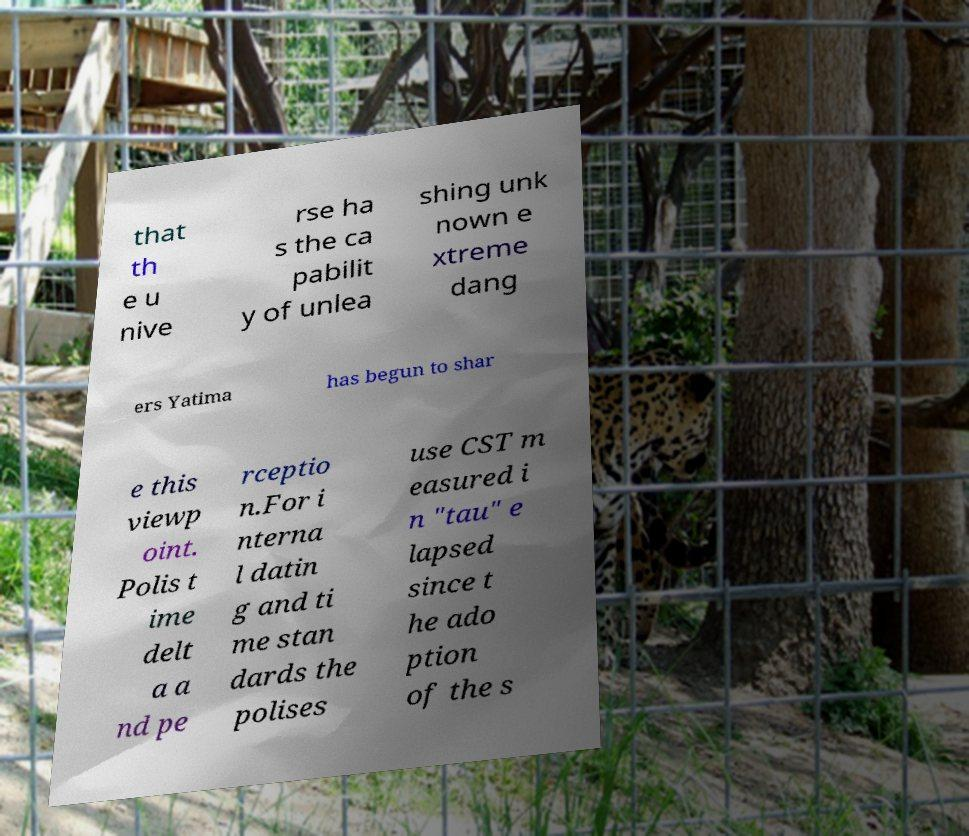I need the written content from this picture converted into text. Can you do that? that th e u nive rse ha s the ca pabilit y of unlea shing unk nown e xtreme dang ers Yatima has begun to shar e this viewp oint. Polis t ime delt a a nd pe rceptio n.For i nterna l datin g and ti me stan dards the polises use CST m easured i n "tau" e lapsed since t he ado ption of the s 